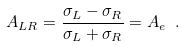<formula> <loc_0><loc_0><loc_500><loc_500>A _ { L R } = \frac { \sigma _ { L } - \sigma _ { R } } { \sigma _ { L } + \sigma _ { R } } = A _ { e } \ .</formula> 